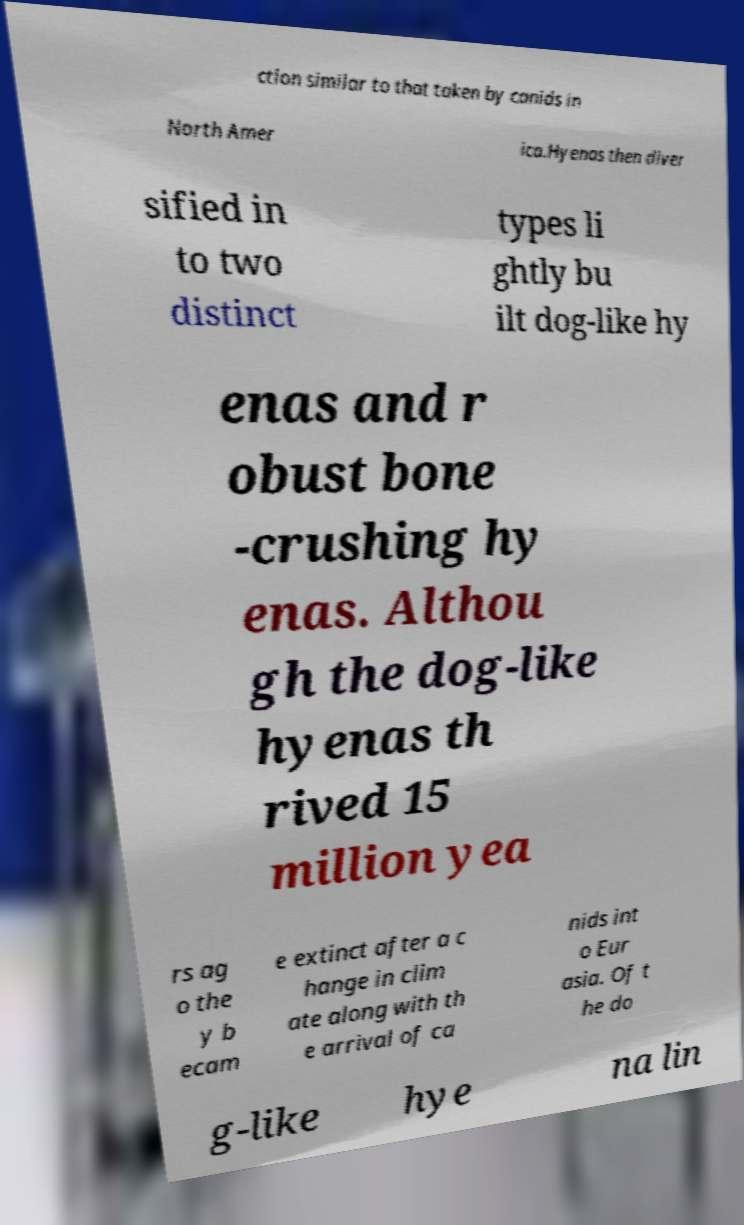I need the written content from this picture converted into text. Can you do that? ction similar to that taken by canids in North Amer ica.Hyenas then diver sified in to two distinct types li ghtly bu ilt dog-like hy enas and r obust bone -crushing hy enas. Althou gh the dog-like hyenas th rived 15 million yea rs ag o the y b ecam e extinct after a c hange in clim ate along with th e arrival of ca nids int o Eur asia. Of t he do g-like hye na lin 